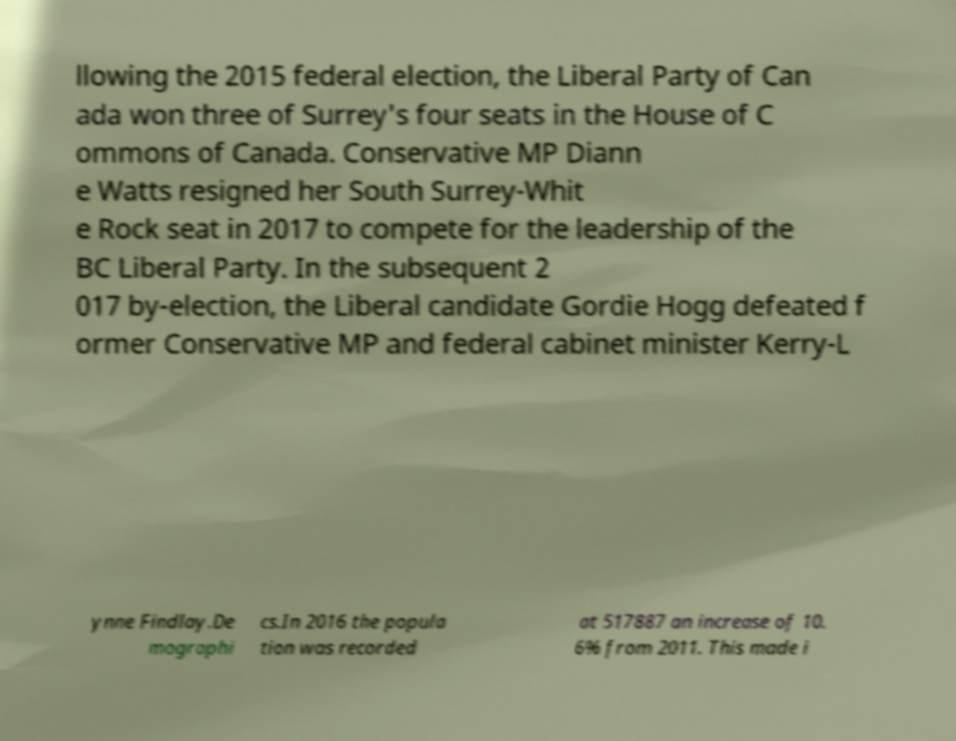Can you accurately transcribe the text from the provided image for me? llowing the 2015 federal election, the Liberal Party of Can ada won three of Surrey's four seats in the House of C ommons of Canada. Conservative MP Diann e Watts resigned her South Surrey-Whit e Rock seat in 2017 to compete for the leadership of the BC Liberal Party. In the subsequent 2 017 by-election, the Liberal candidate Gordie Hogg defeated f ormer Conservative MP and federal cabinet minister Kerry-L ynne Findlay.De mographi cs.In 2016 the popula tion was recorded at 517887 an increase of 10. 6% from 2011. This made i 